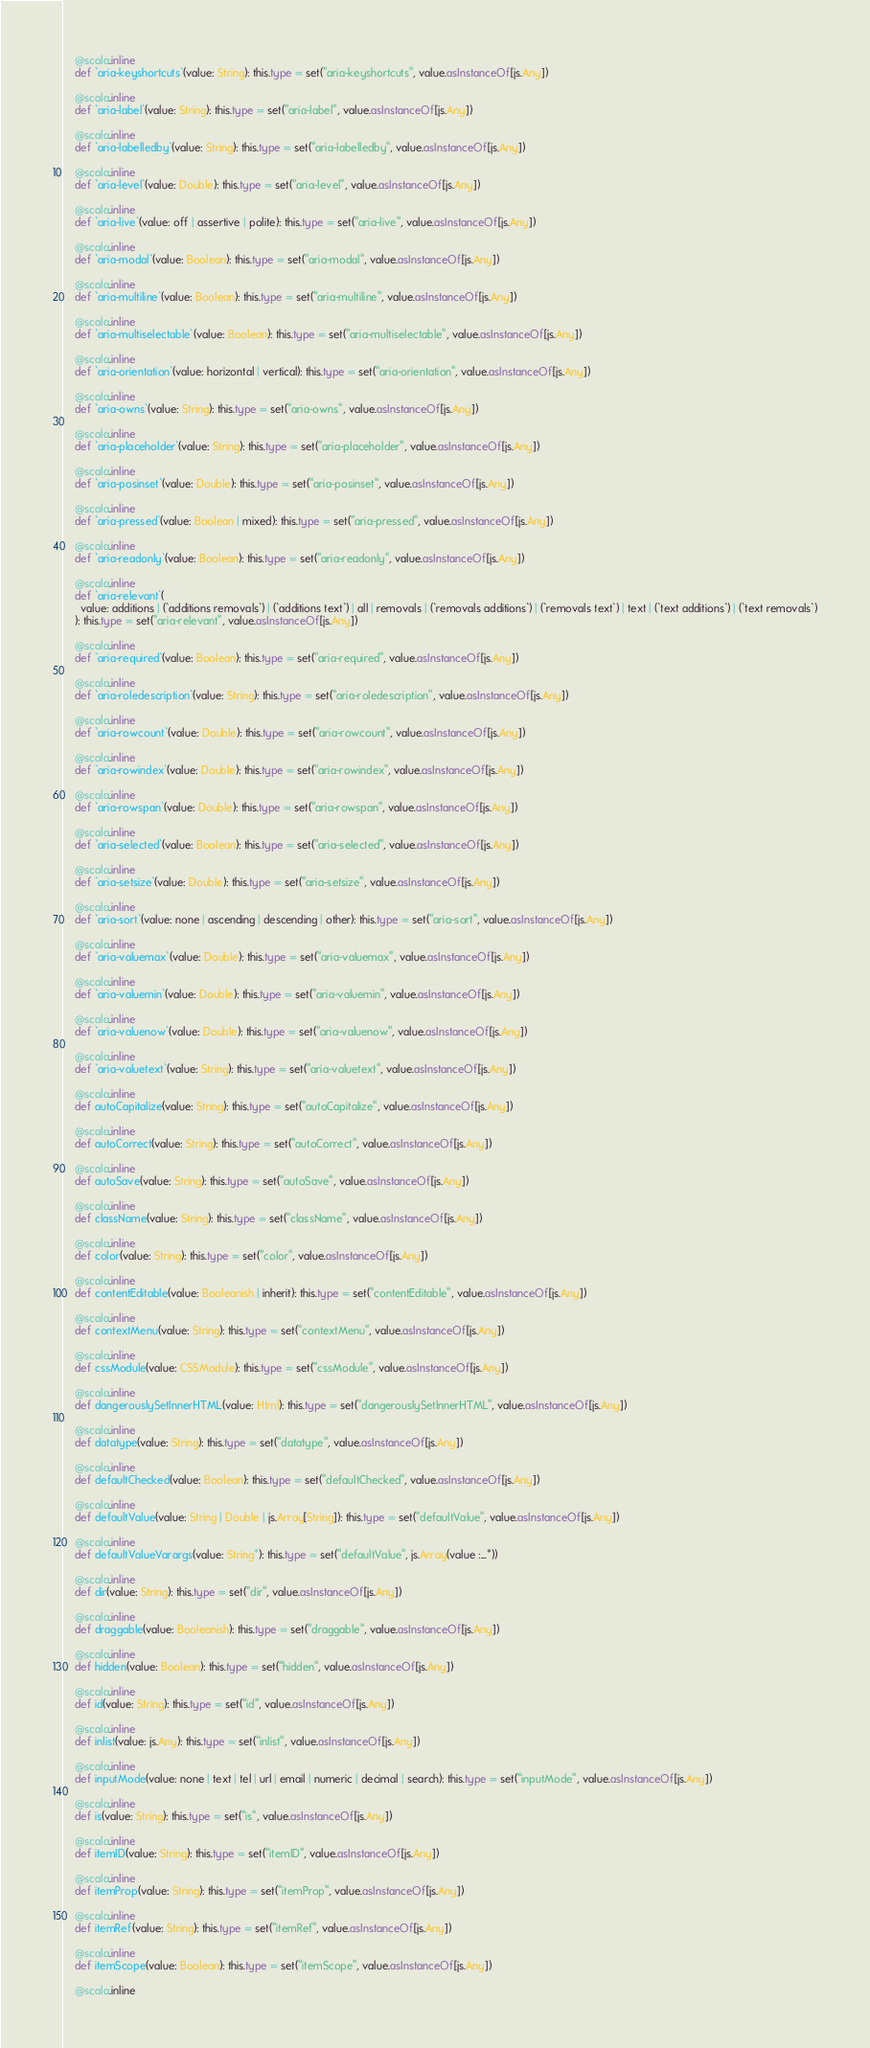Convert code to text. <code><loc_0><loc_0><loc_500><loc_500><_Scala_>    @scala.inline
    def `aria-keyshortcuts`(value: String): this.type = set("aria-keyshortcuts", value.asInstanceOf[js.Any])
    
    @scala.inline
    def `aria-label`(value: String): this.type = set("aria-label", value.asInstanceOf[js.Any])
    
    @scala.inline
    def `aria-labelledby`(value: String): this.type = set("aria-labelledby", value.asInstanceOf[js.Any])
    
    @scala.inline
    def `aria-level`(value: Double): this.type = set("aria-level", value.asInstanceOf[js.Any])
    
    @scala.inline
    def `aria-live`(value: off | assertive | polite): this.type = set("aria-live", value.asInstanceOf[js.Any])
    
    @scala.inline
    def `aria-modal`(value: Boolean): this.type = set("aria-modal", value.asInstanceOf[js.Any])
    
    @scala.inline
    def `aria-multiline`(value: Boolean): this.type = set("aria-multiline", value.asInstanceOf[js.Any])
    
    @scala.inline
    def `aria-multiselectable`(value: Boolean): this.type = set("aria-multiselectable", value.asInstanceOf[js.Any])
    
    @scala.inline
    def `aria-orientation`(value: horizontal | vertical): this.type = set("aria-orientation", value.asInstanceOf[js.Any])
    
    @scala.inline
    def `aria-owns`(value: String): this.type = set("aria-owns", value.asInstanceOf[js.Any])
    
    @scala.inline
    def `aria-placeholder`(value: String): this.type = set("aria-placeholder", value.asInstanceOf[js.Any])
    
    @scala.inline
    def `aria-posinset`(value: Double): this.type = set("aria-posinset", value.asInstanceOf[js.Any])
    
    @scala.inline
    def `aria-pressed`(value: Boolean | mixed): this.type = set("aria-pressed", value.asInstanceOf[js.Any])
    
    @scala.inline
    def `aria-readonly`(value: Boolean): this.type = set("aria-readonly", value.asInstanceOf[js.Any])
    
    @scala.inline
    def `aria-relevant`(
      value: additions | (`additions removals`) | (`additions text`) | all | removals | (`removals additions`) | (`removals text`) | text | (`text additions`) | (`text removals`)
    ): this.type = set("aria-relevant", value.asInstanceOf[js.Any])
    
    @scala.inline
    def `aria-required`(value: Boolean): this.type = set("aria-required", value.asInstanceOf[js.Any])
    
    @scala.inline
    def `aria-roledescription`(value: String): this.type = set("aria-roledescription", value.asInstanceOf[js.Any])
    
    @scala.inline
    def `aria-rowcount`(value: Double): this.type = set("aria-rowcount", value.asInstanceOf[js.Any])
    
    @scala.inline
    def `aria-rowindex`(value: Double): this.type = set("aria-rowindex", value.asInstanceOf[js.Any])
    
    @scala.inline
    def `aria-rowspan`(value: Double): this.type = set("aria-rowspan", value.asInstanceOf[js.Any])
    
    @scala.inline
    def `aria-selected`(value: Boolean): this.type = set("aria-selected", value.asInstanceOf[js.Any])
    
    @scala.inline
    def `aria-setsize`(value: Double): this.type = set("aria-setsize", value.asInstanceOf[js.Any])
    
    @scala.inline
    def `aria-sort`(value: none | ascending | descending | other): this.type = set("aria-sort", value.asInstanceOf[js.Any])
    
    @scala.inline
    def `aria-valuemax`(value: Double): this.type = set("aria-valuemax", value.asInstanceOf[js.Any])
    
    @scala.inline
    def `aria-valuemin`(value: Double): this.type = set("aria-valuemin", value.asInstanceOf[js.Any])
    
    @scala.inline
    def `aria-valuenow`(value: Double): this.type = set("aria-valuenow", value.asInstanceOf[js.Any])
    
    @scala.inline
    def `aria-valuetext`(value: String): this.type = set("aria-valuetext", value.asInstanceOf[js.Any])
    
    @scala.inline
    def autoCapitalize(value: String): this.type = set("autoCapitalize", value.asInstanceOf[js.Any])
    
    @scala.inline
    def autoCorrect(value: String): this.type = set("autoCorrect", value.asInstanceOf[js.Any])
    
    @scala.inline
    def autoSave(value: String): this.type = set("autoSave", value.asInstanceOf[js.Any])
    
    @scala.inline
    def className(value: String): this.type = set("className", value.asInstanceOf[js.Any])
    
    @scala.inline
    def color(value: String): this.type = set("color", value.asInstanceOf[js.Any])
    
    @scala.inline
    def contentEditable(value: Booleanish | inherit): this.type = set("contentEditable", value.asInstanceOf[js.Any])
    
    @scala.inline
    def contextMenu(value: String): this.type = set("contextMenu", value.asInstanceOf[js.Any])
    
    @scala.inline
    def cssModule(value: CSSModule): this.type = set("cssModule", value.asInstanceOf[js.Any])
    
    @scala.inline
    def dangerouslySetInnerHTML(value: Html): this.type = set("dangerouslySetInnerHTML", value.asInstanceOf[js.Any])
    
    @scala.inline
    def datatype(value: String): this.type = set("datatype", value.asInstanceOf[js.Any])
    
    @scala.inline
    def defaultChecked(value: Boolean): this.type = set("defaultChecked", value.asInstanceOf[js.Any])
    
    @scala.inline
    def defaultValue(value: String | Double | js.Array[String]): this.type = set("defaultValue", value.asInstanceOf[js.Any])
    
    @scala.inline
    def defaultValueVarargs(value: String*): this.type = set("defaultValue", js.Array(value :_*))
    
    @scala.inline
    def dir(value: String): this.type = set("dir", value.asInstanceOf[js.Any])
    
    @scala.inline
    def draggable(value: Booleanish): this.type = set("draggable", value.asInstanceOf[js.Any])
    
    @scala.inline
    def hidden(value: Boolean): this.type = set("hidden", value.asInstanceOf[js.Any])
    
    @scala.inline
    def id(value: String): this.type = set("id", value.asInstanceOf[js.Any])
    
    @scala.inline
    def inlist(value: js.Any): this.type = set("inlist", value.asInstanceOf[js.Any])
    
    @scala.inline
    def inputMode(value: none | text | tel | url | email | numeric | decimal | search): this.type = set("inputMode", value.asInstanceOf[js.Any])
    
    @scala.inline
    def is(value: String): this.type = set("is", value.asInstanceOf[js.Any])
    
    @scala.inline
    def itemID(value: String): this.type = set("itemID", value.asInstanceOf[js.Any])
    
    @scala.inline
    def itemProp(value: String): this.type = set("itemProp", value.asInstanceOf[js.Any])
    
    @scala.inline
    def itemRef(value: String): this.type = set("itemRef", value.asInstanceOf[js.Any])
    
    @scala.inline
    def itemScope(value: Boolean): this.type = set("itemScope", value.asInstanceOf[js.Any])
    
    @scala.inline</code> 